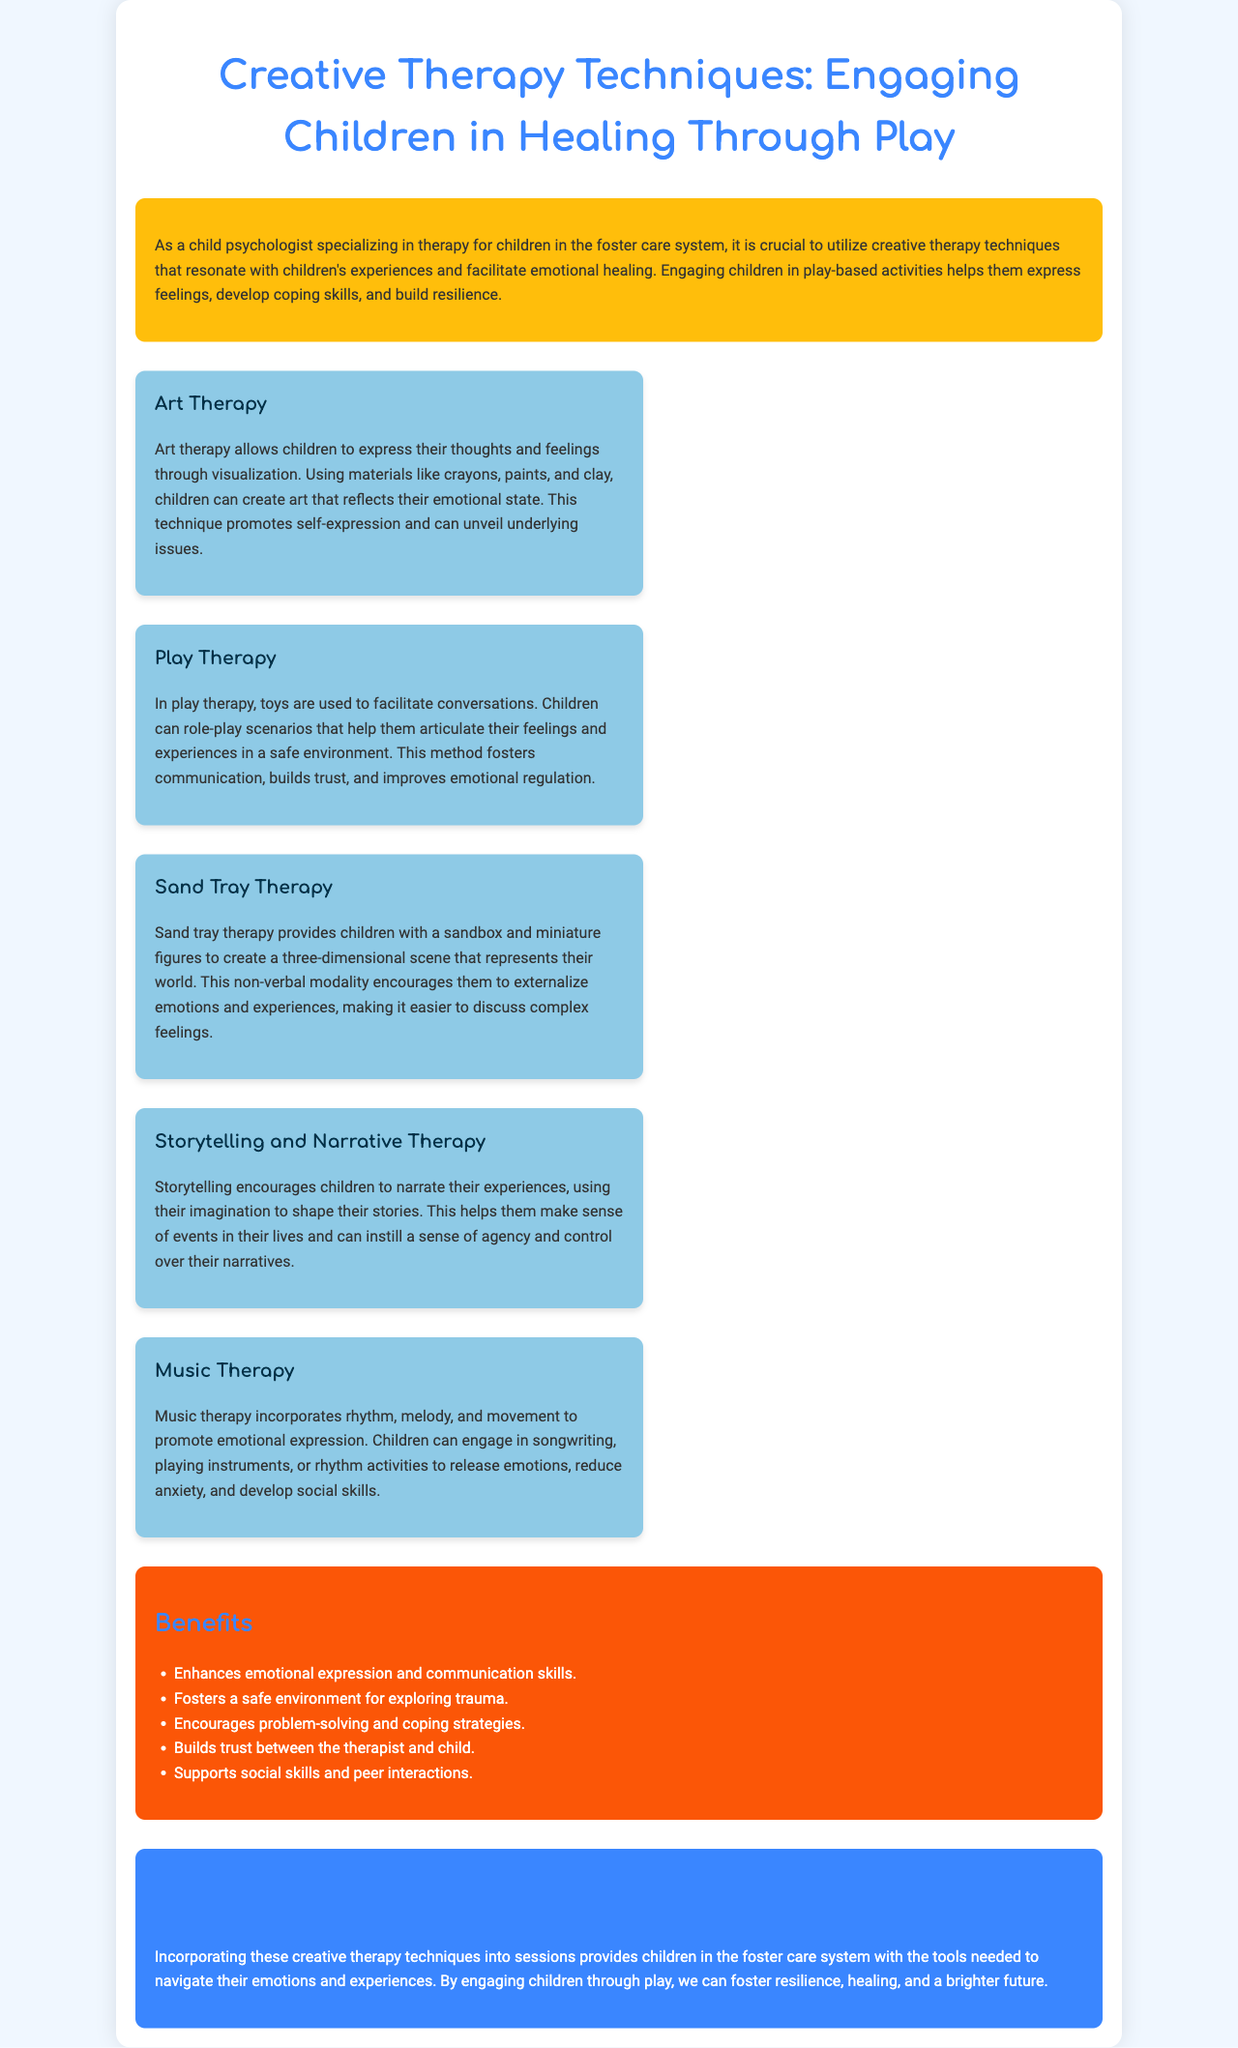What is the title of the brochure? The title is prominently displayed at the top of the document, stating the focus of the content.
Answer: Creative Therapy Techniques: Engaging Children in Healing Through Play What is one technique mentioned in the brochure? The brochure lists multiple therapy techniques for children, one of which can be cited directly from the content.
Answer: Art Therapy How many techniques are described in the brochure? The document provides a list of different therapeutic techniques, and counting them gives the total number.
Answer: Five What color is used for the benefits section? The brochure visually indicates sections through color coding, specifically used for the benefits area.
Answer: Orange What does sand tray therapy encourage? The description under sand tray therapy outlines the primary function and benefit of the technique used for children.
Answer: Externalizing emotions What is a stated benefit of creative therapy techniques? The brochure lists multiple benefits that result from the implementation of the described techniques focusing on emotional outcomes.
Answer: Enhances emotional expression What therapeutic technique involves music? The brochure specifies techniques and links them to different forms of art and expression, including the one related to music.
Answer: Music Therapy What is the primary focus of the document? The introduction of the brochure outlines the main purpose behind creating the content and its intended audience.
Answer: Engaging children in healing through play What is the ultimate aim of incorporating these techniques? The conclusion summarizes the overarching goal of applying creative therapy techniques in therapeutic settings for children.
Answer: Foster resilience, healing, and a brighter future 